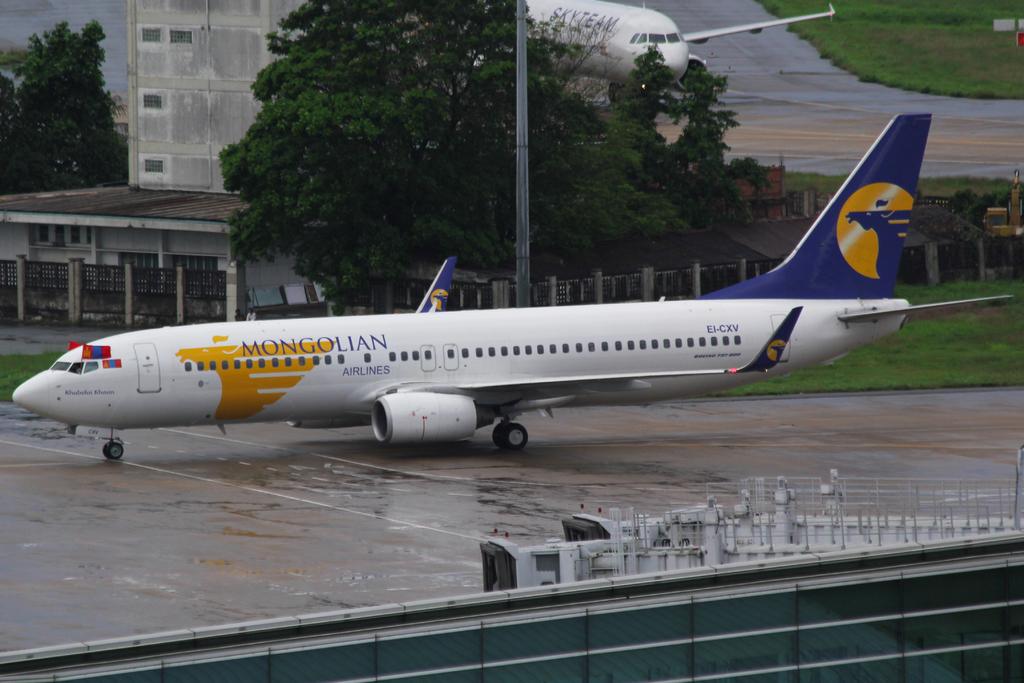What letters are on the plane near the tail?
Offer a terse response. Ei-cxv. What airline company does this plane represent?
Offer a very short reply. Mongolian. 